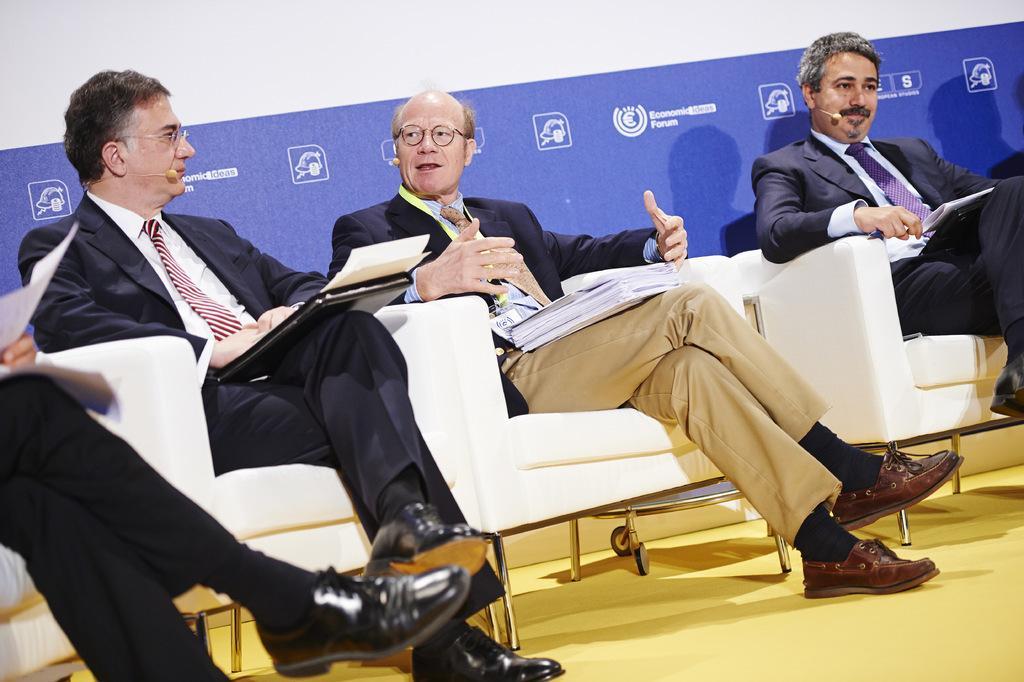In one or two sentences, can you explain what this image depicts? The image is clicked on a stage might be in a conference. On the stage there are couches, people and banner. The people are holding files, papers and there are wearing mics. In the center the person is talking. 